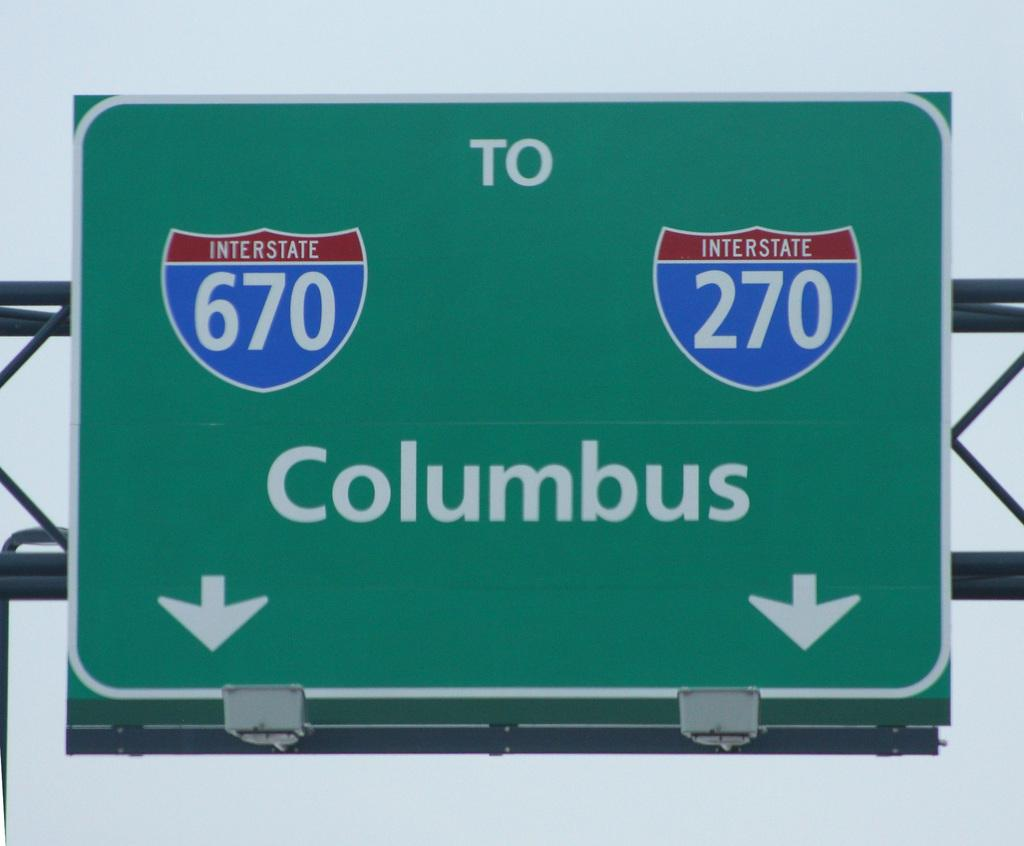<image>
Describe the image concisely. A green highway sign pointing the way to Columbus 